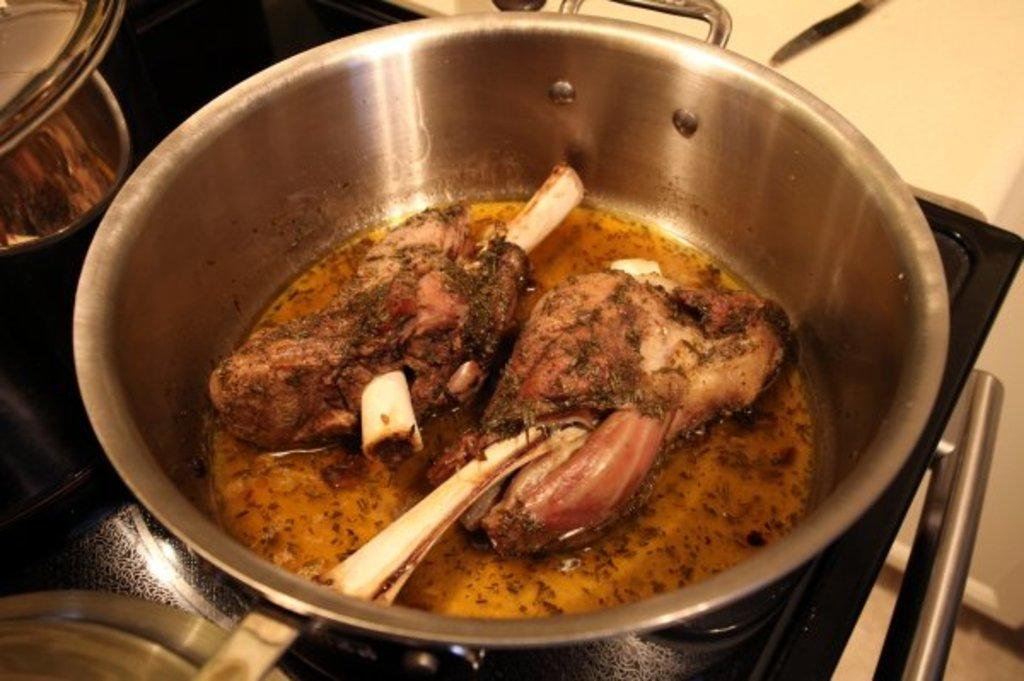What type of food is in the steel vessel in the image? There is a chicken curry in a steel vessel in the image. What is the steel vessel placed on? The steel vessel is placed on a black color stove. What color is the wall visible in the background of the image? There is a yellow color wall in the background of the image. How many eyes can be seen on the guitar in the image? There is no guitar present in the image; it features a chicken curry in a steel vessel placed on a black color stove with a yellow color wall in the background. 